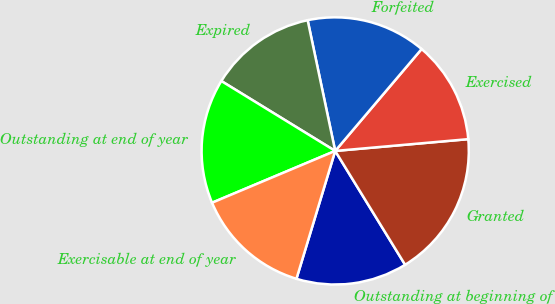<chart> <loc_0><loc_0><loc_500><loc_500><pie_chart><fcel>Outstanding at beginning of<fcel>Granted<fcel>Exercised<fcel>Forfeited<fcel>Expired<fcel>Outstanding at end of year<fcel>Exercisable at end of year<nl><fcel>13.45%<fcel>17.64%<fcel>12.4%<fcel>14.5%<fcel>12.93%<fcel>15.1%<fcel>13.98%<nl></chart> 